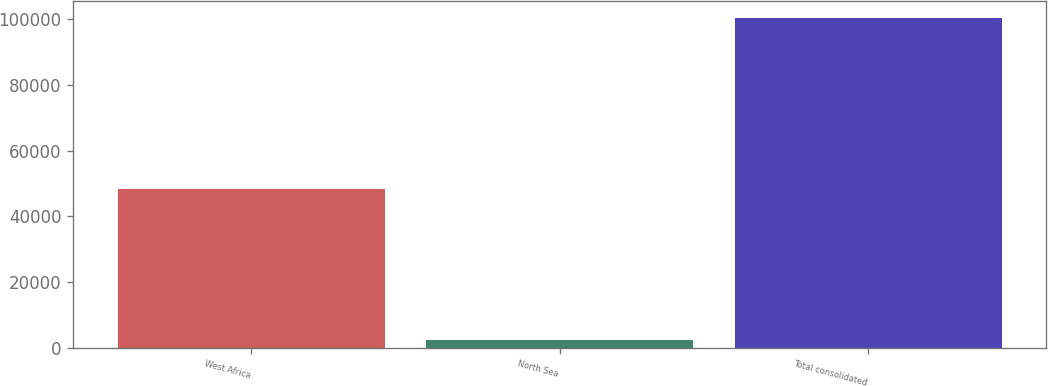Convert chart. <chart><loc_0><loc_0><loc_500><loc_500><bar_chart><fcel>West Africa<fcel>North Sea<fcel>Total consolidated<nl><fcel>48349<fcel>2276<fcel>100459<nl></chart> 